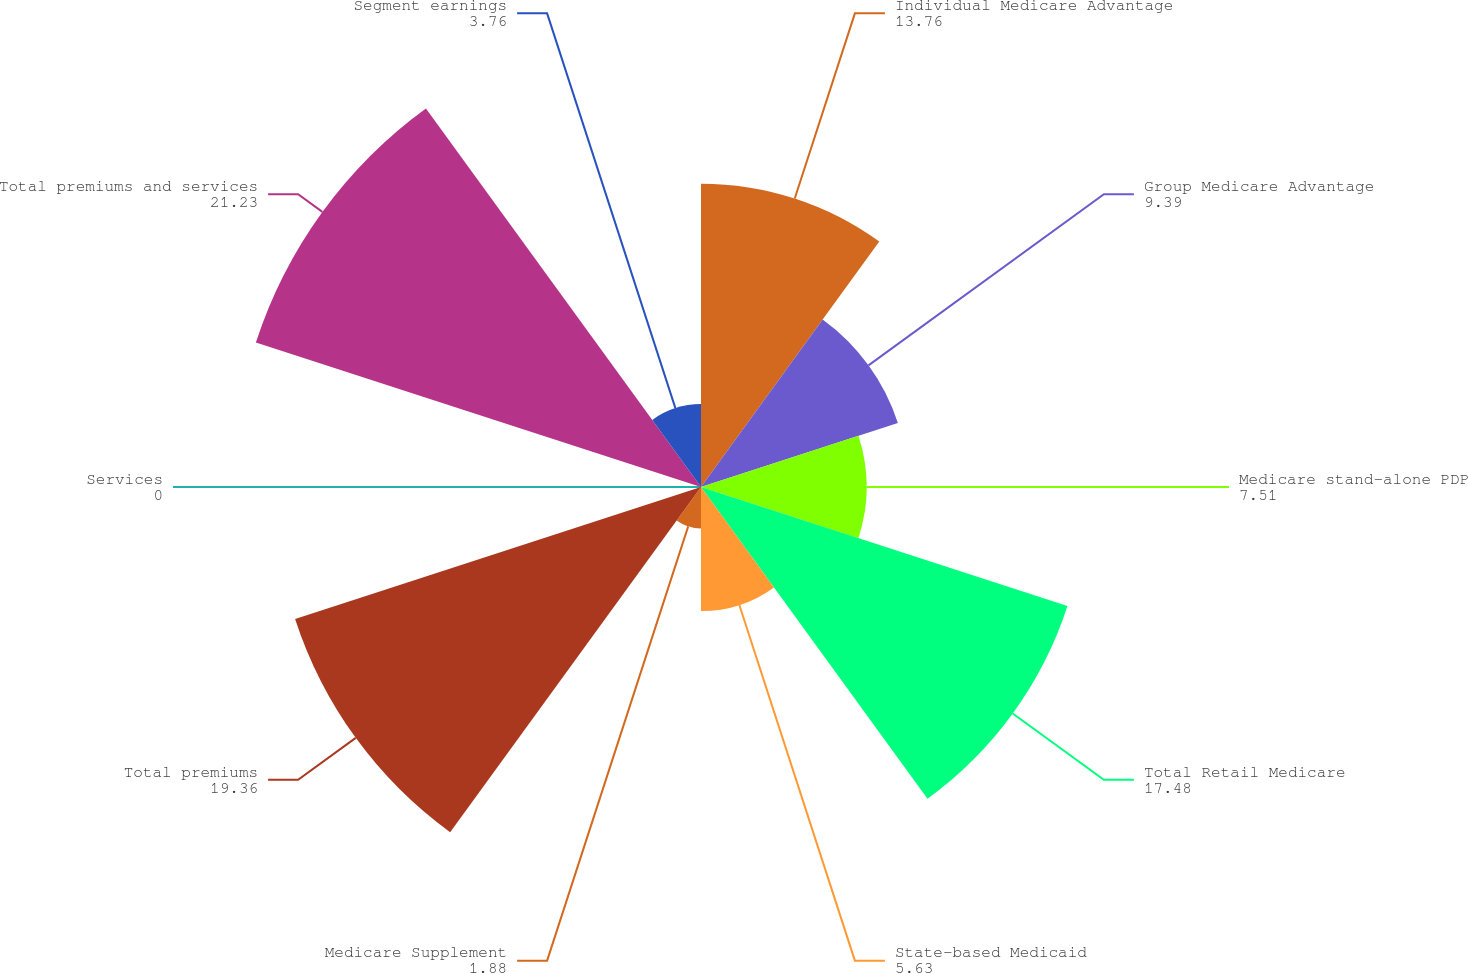Convert chart to OTSL. <chart><loc_0><loc_0><loc_500><loc_500><pie_chart><fcel>Individual Medicare Advantage<fcel>Group Medicare Advantage<fcel>Medicare stand-alone PDP<fcel>Total Retail Medicare<fcel>State-based Medicaid<fcel>Medicare Supplement<fcel>Total premiums<fcel>Services<fcel>Total premiums and services<fcel>Segment earnings<nl><fcel>13.76%<fcel>9.39%<fcel>7.51%<fcel>17.48%<fcel>5.63%<fcel>1.88%<fcel>19.36%<fcel>0.0%<fcel>21.23%<fcel>3.76%<nl></chart> 